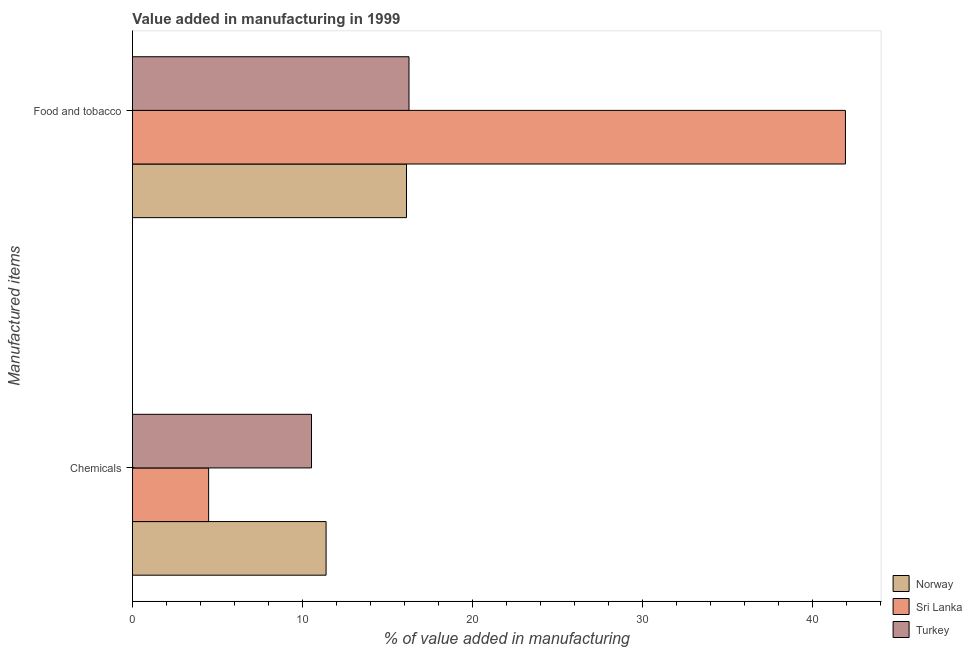How many groups of bars are there?
Offer a terse response. 2. Are the number of bars per tick equal to the number of legend labels?
Make the answer very short. Yes. Are the number of bars on each tick of the Y-axis equal?
Give a very brief answer. Yes. How many bars are there on the 1st tick from the bottom?
Give a very brief answer. 3. What is the label of the 1st group of bars from the top?
Your answer should be very brief. Food and tobacco. What is the value added by manufacturing food and tobacco in Turkey?
Keep it short and to the point. 16.27. Across all countries, what is the maximum value added by  manufacturing chemicals?
Provide a succinct answer. 11.39. Across all countries, what is the minimum value added by  manufacturing chemicals?
Make the answer very short. 4.48. In which country was the value added by manufacturing food and tobacco maximum?
Your response must be concise. Sri Lanka. In which country was the value added by manufacturing food and tobacco minimum?
Offer a terse response. Norway. What is the total value added by manufacturing food and tobacco in the graph?
Give a very brief answer. 74.34. What is the difference between the value added by  manufacturing chemicals in Norway and that in Turkey?
Make the answer very short. 0.86. What is the difference between the value added by  manufacturing chemicals in Sri Lanka and the value added by manufacturing food and tobacco in Turkey?
Make the answer very short. -11.79. What is the average value added by  manufacturing chemicals per country?
Offer a very short reply. 8.8. What is the difference between the value added by manufacturing food and tobacco and value added by  manufacturing chemicals in Turkey?
Offer a terse response. 5.74. In how many countries, is the value added by manufacturing food and tobacco greater than 30 %?
Provide a short and direct response. 1. What is the ratio of the value added by  manufacturing chemicals in Norway to that in Turkey?
Ensure brevity in your answer.  1.08. What does the 1st bar from the top in Chemicals represents?
Provide a short and direct response. Turkey. What does the 2nd bar from the bottom in Chemicals represents?
Give a very brief answer. Sri Lanka. Are all the bars in the graph horizontal?
Ensure brevity in your answer.  Yes. Does the graph contain grids?
Provide a short and direct response. No. How many legend labels are there?
Your answer should be compact. 3. How are the legend labels stacked?
Your answer should be very brief. Vertical. What is the title of the graph?
Offer a very short reply. Value added in manufacturing in 1999. Does "Cayman Islands" appear as one of the legend labels in the graph?
Keep it short and to the point. No. What is the label or title of the X-axis?
Give a very brief answer. % of value added in manufacturing. What is the label or title of the Y-axis?
Offer a very short reply. Manufactured items. What is the % of value added in manufacturing of Norway in Chemicals?
Your answer should be very brief. 11.39. What is the % of value added in manufacturing of Sri Lanka in Chemicals?
Provide a succinct answer. 4.48. What is the % of value added in manufacturing of Turkey in Chemicals?
Your answer should be compact. 10.53. What is the % of value added in manufacturing in Norway in Food and tobacco?
Offer a terse response. 16.12. What is the % of value added in manufacturing of Sri Lanka in Food and tobacco?
Make the answer very short. 41.94. What is the % of value added in manufacturing in Turkey in Food and tobacco?
Make the answer very short. 16.27. Across all Manufactured items, what is the maximum % of value added in manufacturing of Norway?
Offer a very short reply. 16.12. Across all Manufactured items, what is the maximum % of value added in manufacturing of Sri Lanka?
Ensure brevity in your answer.  41.94. Across all Manufactured items, what is the maximum % of value added in manufacturing in Turkey?
Offer a very short reply. 16.27. Across all Manufactured items, what is the minimum % of value added in manufacturing in Norway?
Your response must be concise. 11.39. Across all Manufactured items, what is the minimum % of value added in manufacturing in Sri Lanka?
Your response must be concise. 4.48. Across all Manufactured items, what is the minimum % of value added in manufacturing in Turkey?
Offer a terse response. 10.53. What is the total % of value added in manufacturing of Norway in the graph?
Provide a short and direct response. 27.51. What is the total % of value added in manufacturing in Sri Lanka in the graph?
Give a very brief answer. 46.43. What is the total % of value added in manufacturing in Turkey in the graph?
Ensure brevity in your answer.  26.8. What is the difference between the % of value added in manufacturing of Norway in Chemicals and that in Food and tobacco?
Provide a short and direct response. -4.73. What is the difference between the % of value added in manufacturing of Sri Lanka in Chemicals and that in Food and tobacco?
Your answer should be compact. -37.46. What is the difference between the % of value added in manufacturing in Turkey in Chemicals and that in Food and tobacco?
Offer a very short reply. -5.74. What is the difference between the % of value added in manufacturing in Norway in Chemicals and the % of value added in manufacturing in Sri Lanka in Food and tobacco?
Your answer should be compact. -30.55. What is the difference between the % of value added in manufacturing in Norway in Chemicals and the % of value added in manufacturing in Turkey in Food and tobacco?
Your response must be concise. -4.88. What is the difference between the % of value added in manufacturing of Sri Lanka in Chemicals and the % of value added in manufacturing of Turkey in Food and tobacco?
Keep it short and to the point. -11.79. What is the average % of value added in manufacturing of Norway per Manufactured items?
Provide a succinct answer. 13.76. What is the average % of value added in manufacturing of Sri Lanka per Manufactured items?
Give a very brief answer. 23.21. What is the average % of value added in manufacturing of Turkey per Manufactured items?
Your response must be concise. 13.4. What is the difference between the % of value added in manufacturing in Norway and % of value added in manufacturing in Sri Lanka in Chemicals?
Offer a terse response. 6.91. What is the difference between the % of value added in manufacturing of Norway and % of value added in manufacturing of Turkey in Chemicals?
Provide a succinct answer. 0.86. What is the difference between the % of value added in manufacturing of Sri Lanka and % of value added in manufacturing of Turkey in Chemicals?
Keep it short and to the point. -6.05. What is the difference between the % of value added in manufacturing in Norway and % of value added in manufacturing in Sri Lanka in Food and tobacco?
Offer a terse response. -25.82. What is the difference between the % of value added in manufacturing of Norway and % of value added in manufacturing of Turkey in Food and tobacco?
Your response must be concise. -0.15. What is the difference between the % of value added in manufacturing in Sri Lanka and % of value added in manufacturing in Turkey in Food and tobacco?
Provide a succinct answer. 25.67. What is the ratio of the % of value added in manufacturing in Norway in Chemicals to that in Food and tobacco?
Your answer should be compact. 0.71. What is the ratio of the % of value added in manufacturing of Sri Lanka in Chemicals to that in Food and tobacco?
Your answer should be compact. 0.11. What is the ratio of the % of value added in manufacturing of Turkey in Chemicals to that in Food and tobacco?
Provide a short and direct response. 0.65. What is the difference between the highest and the second highest % of value added in manufacturing of Norway?
Offer a terse response. 4.73. What is the difference between the highest and the second highest % of value added in manufacturing of Sri Lanka?
Provide a succinct answer. 37.46. What is the difference between the highest and the second highest % of value added in manufacturing of Turkey?
Your answer should be very brief. 5.74. What is the difference between the highest and the lowest % of value added in manufacturing of Norway?
Make the answer very short. 4.73. What is the difference between the highest and the lowest % of value added in manufacturing of Sri Lanka?
Offer a terse response. 37.46. What is the difference between the highest and the lowest % of value added in manufacturing of Turkey?
Your answer should be compact. 5.74. 